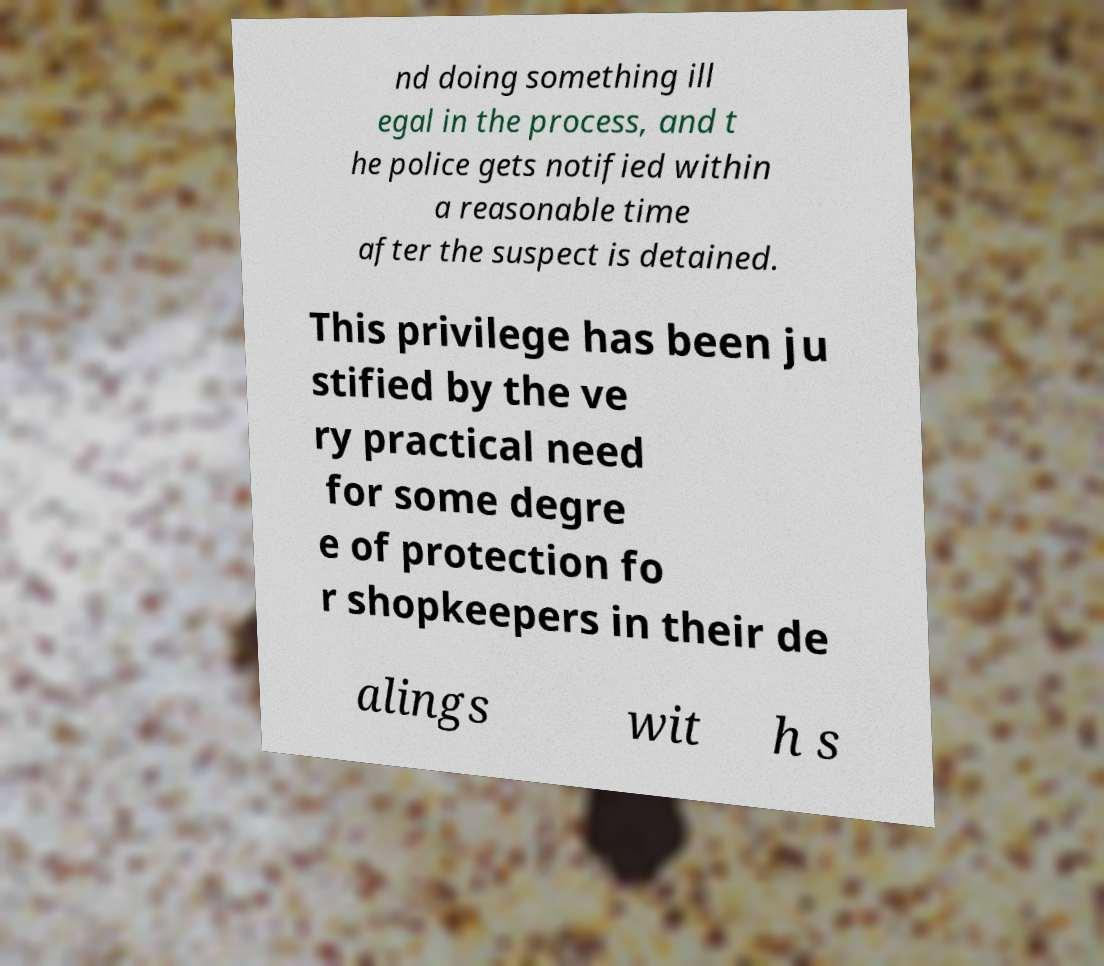For documentation purposes, I need the text within this image transcribed. Could you provide that? nd doing something ill egal in the process, and t he police gets notified within a reasonable time after the suspect is detained. This privilege has been ju stified by the ve ry practical need for some degre e of protection fo r shopkeepers in their de alings wit h s 